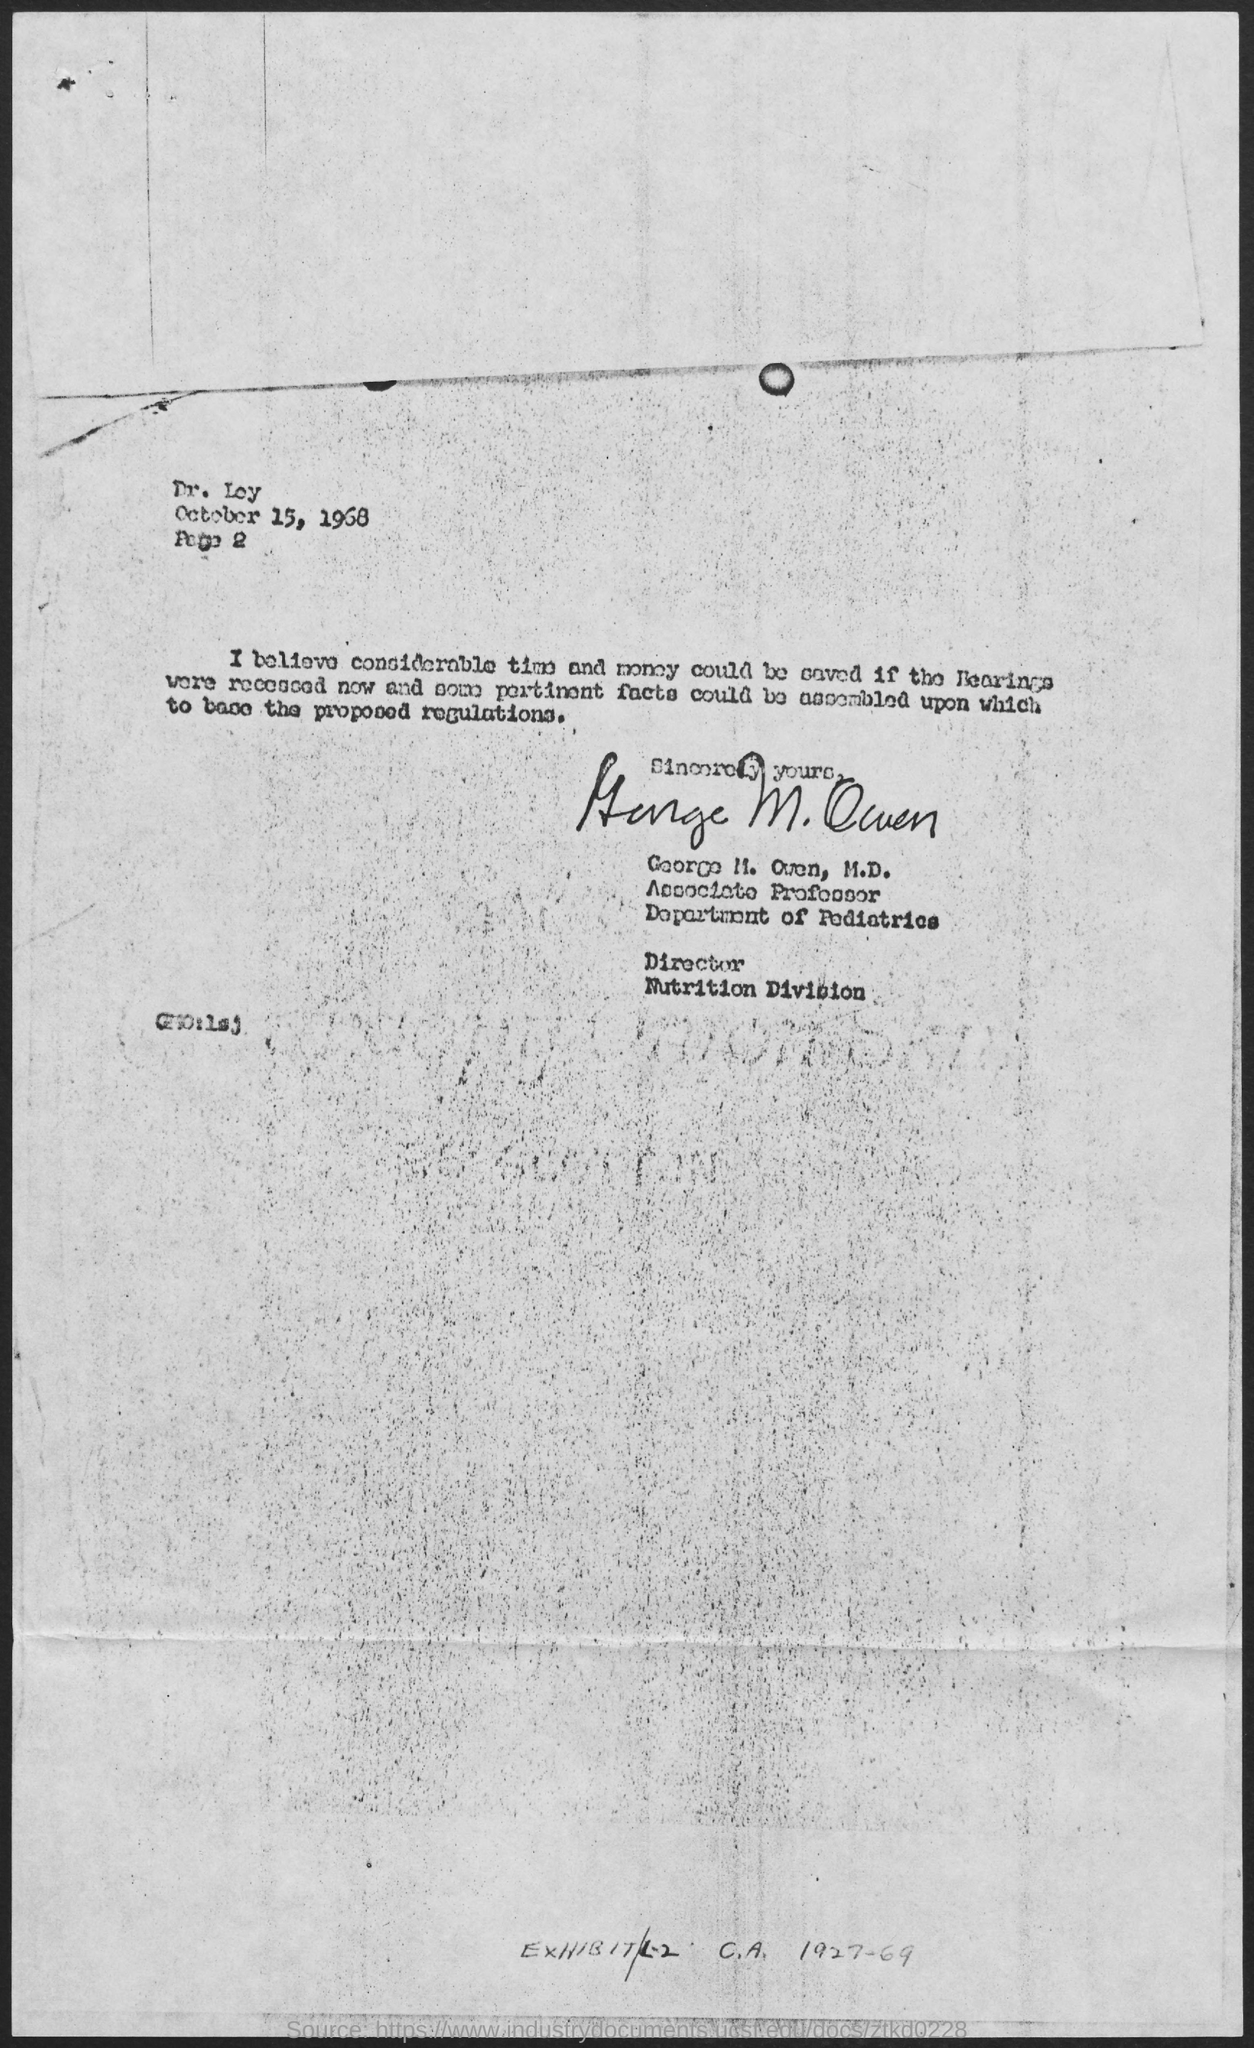Outline some significant characteristics in this image. George M. Owen holds the designation of an associate professor. The date mentioned in the given page is October 15, 1968. George M. Owen belongs to the Department of Pediatrics. 